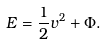<formula> <loc_0><loc_0><loc_500><loc_500>E = \frac { 1 } { 2 } v ^ { 2 } + \Phi .</formula> 